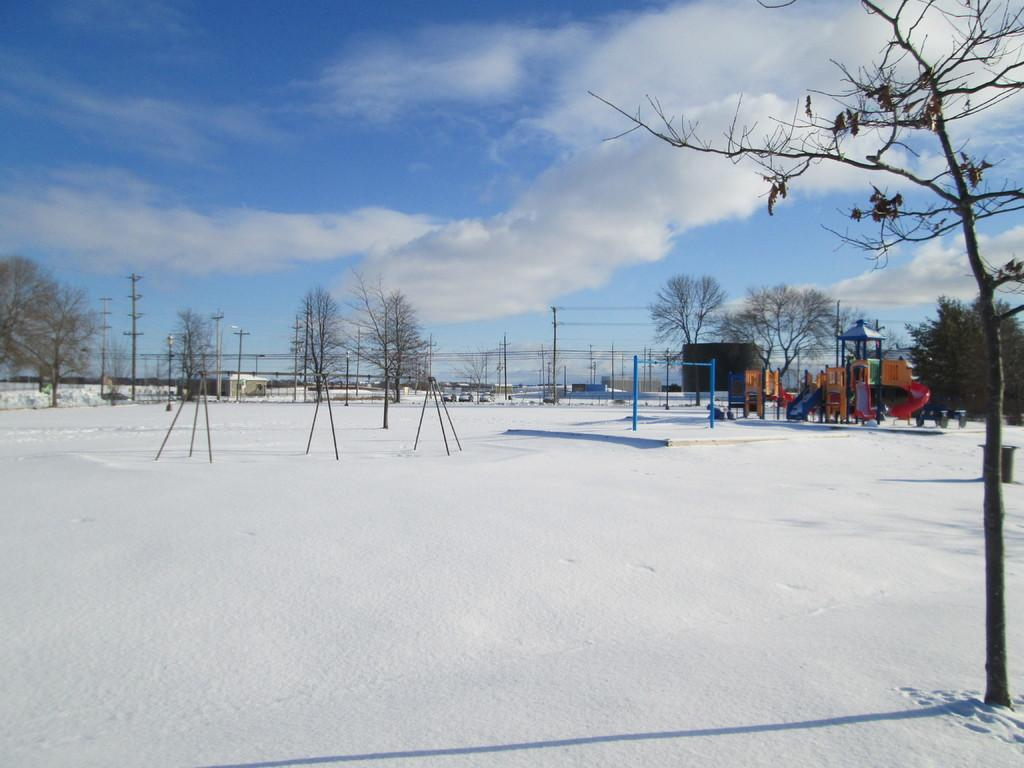What type of vegetation can be seen in the image? There are trees in the image. What structures are present in the image? There are poles in the image. What is the condition of the ground in the image? There is snow on the ground in the image. What type of playground equipment is visible in the image? There is a slide on the right side of the image. What can be seen in the background of the image? There are houses, wires, and clouds in the sky. Can you hear the owl hooting in the image? There is no auditory information provided in the image, and no owl is visible, so it is not possible to determine if an owl is hooting. How quiet is the scene in the image? The image does not provide any information about the level of noise or quietness in the scene. 